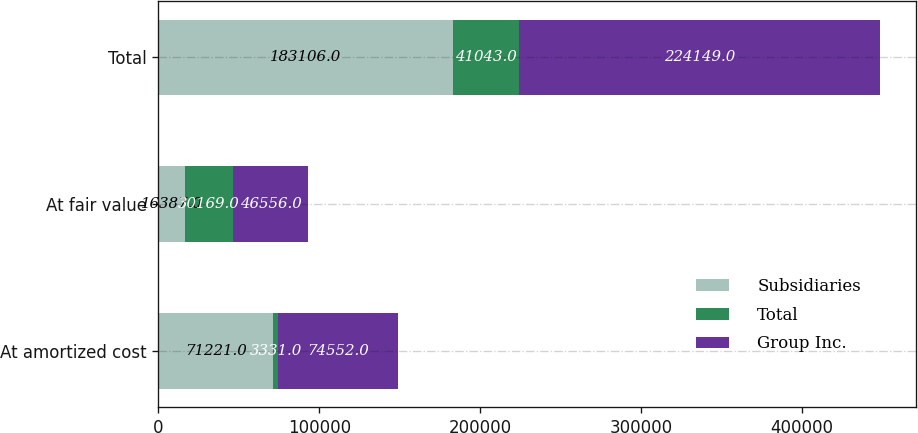<chart> <loc_0><loc_0><loc_500><loc_500><stacked_bar_chart><ecel><fcel>At amortized cost<fcel>At fair value<fcel>Total<nl><fcel>Subsidiaries<fcel>71221<fcel>16387<fcel>183106<nl><fcel>Total<fcel>3331<fcel>30169<fcel>41043<nl><fcel>Group Inc.<fcel>74552<fcel>46556<fcel>224149<nl></chart> 